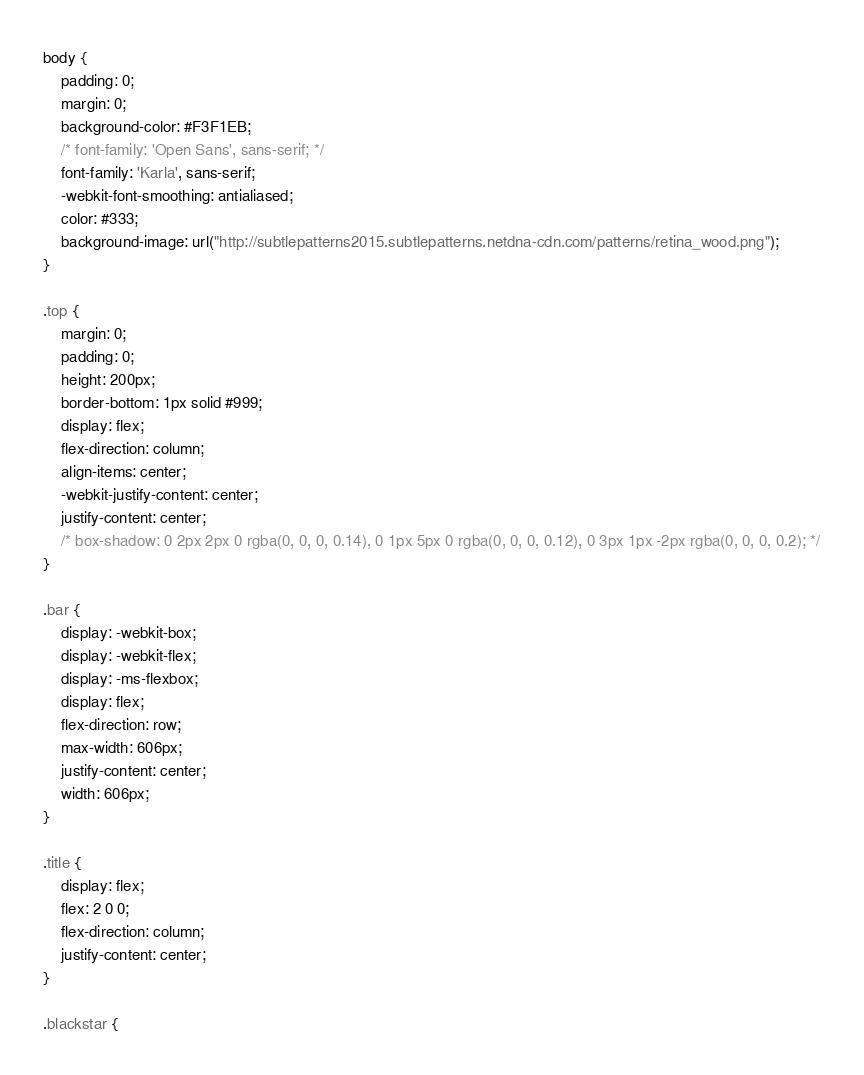<code> <loc_0><loc_0><loc_500><loc_500><_CSS_>body {
    padding: 0;
    margin: 0;
    background-color: #F3F1EB;
    /* font-family: 'Open Sans', sans-serif; */
    font-family: 'Karla', sans-serif;
    -webkit-font-smoothing: antialiased;
    color: #333;
    background-image: url("http://subtlepatterns2015.subtlepatterns.netdna-cdn.com/patterns/retina_wood.png");
}

.top {
    margin: 0;
    padding: 0;
    height: 200px;
    border-bottom: 1px solid #999;
    display: flex;
    flex-direction: column;
    align-items: center;
    -webkit-justify-content: center;
    justify-content: center;
    /* box-shadow: 0 2px 2px 0 rgba(0, 0, 0, 0.14), 0 1px 5px 0 rgba(0, 0, 0, 0.12), 0 3px 1px -2px rgba(0, 0, 0, 0.2); */
}

.bar {
    display: -webkit-box;
    display: -webkit-flex;
    display: -ms-flexbox;
    display: flex;
    flex-direction: row;
    max-width: 606px;
    justify-content: center;
    width: 606px;
}

.title {
    display: flex;
    flex: 2 0 0;
    flex-direction: column;
    justify-content: center;
}

.blackstar {</code> 